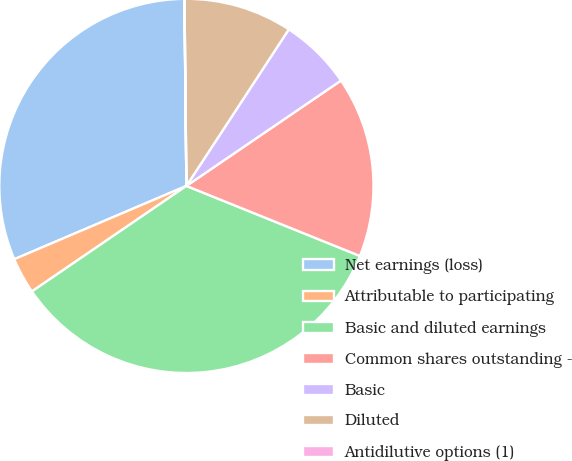<chart> <loc_0><loc_0><loc_500><loc_500><pie_chart><fcel>Net earnings (loss)<fcel>Attributable to participating<fcel>Basic and diluted earnings<fcel>Common shares outstanding -<fcel>Basic<fcel>Diluted<fcel>Antidilutive options (1)<nl><fcel>31.24%<fcel>3.13%<fcel>34.36%<fcel>15.63%<fcel>6.26%<fcel>9.38%<fcel>0.01%<nl></chart> 